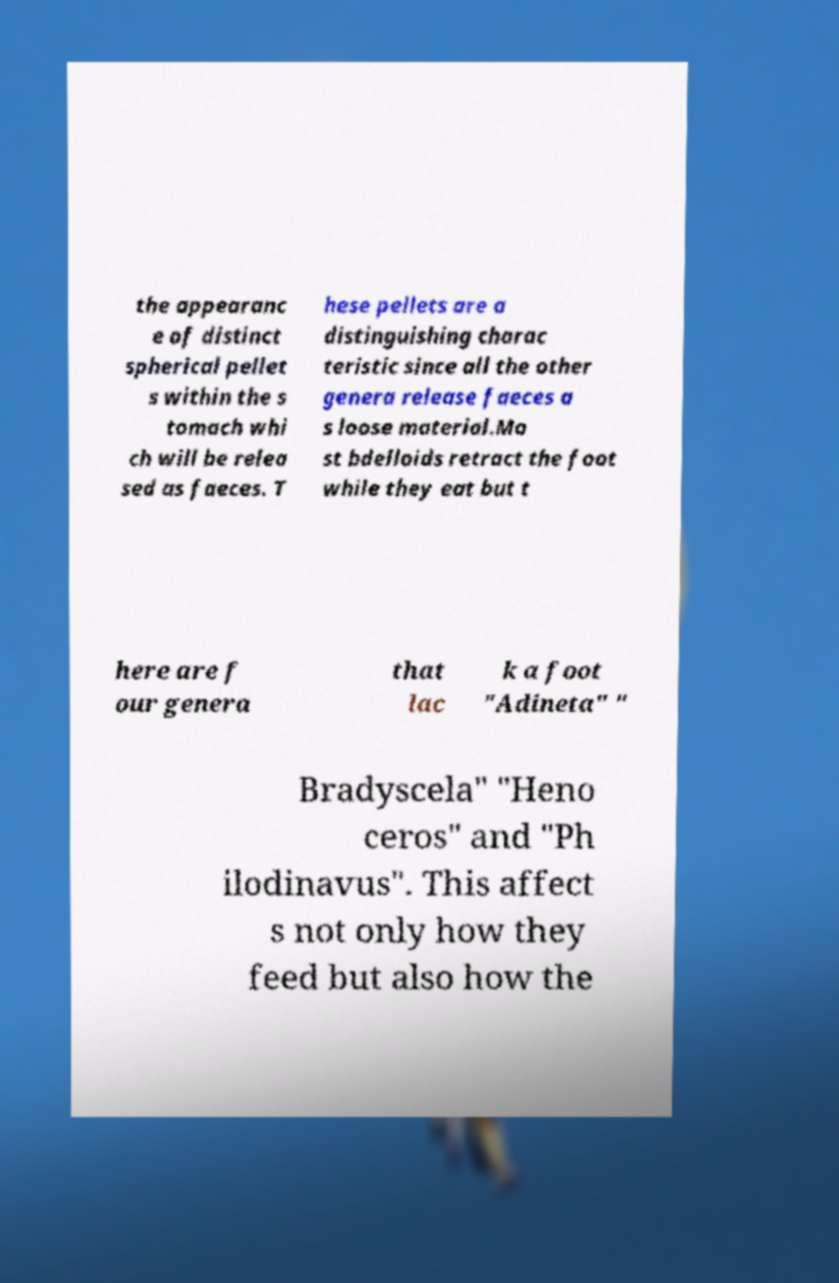What messages or text are displayed in this image? I need them in a readable, typed format. the appearanc e of distinct spherical pellet s within the s tomach whi ch will be relea sed as faeces. T hese pellets are a distinguishing charac teristic since all the other genera release faeces a s loose material.Mo st bdelloids retract the foot while they eat but t here are f our genera that lac k a foot "Adineta" " Bradyscela" "Heno ceros" and "Ph ilodinavus". This affect s not only how they feed but also how the 